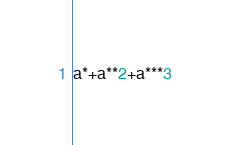<code> <loc_0><loc_0><loc_500><loc_500><_Python_>a*+a**2+a***3</code> 